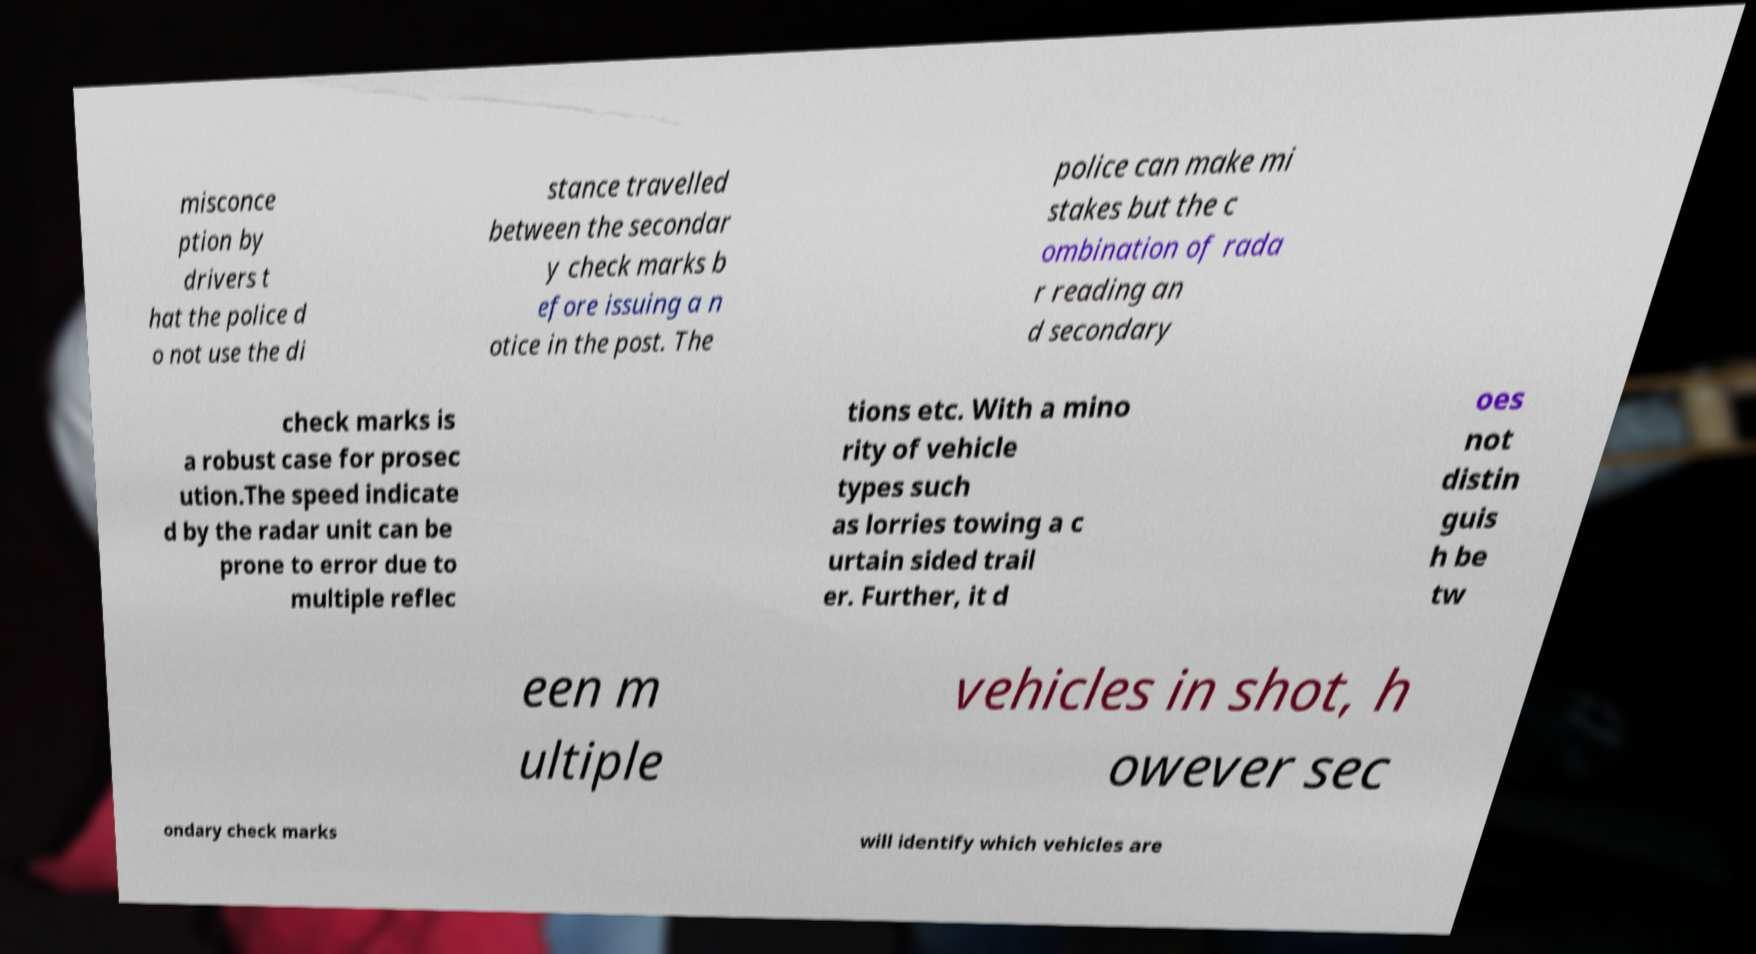Could you assist in decoding the text presented in this image and type it out clearly? misconce ption by drivers t hat the police d o not use the di stance travelled between the secondar y check marks b efore issuing a n otice in the post. The police can make mi stakes but the c ombination of rada r reading an d secondary check marks is a robust case for prosec ution.The speed indicate d by the radar unit can be prone to error due to multiple reflec tions etc. With a mino rity of vehicle types such as lorries towing a c urtain sided trail er. Further, it d oes not distin guis h be tw een m ultiple vehicles in shot, h owever sec ondary check marks will identify which vehicles are 